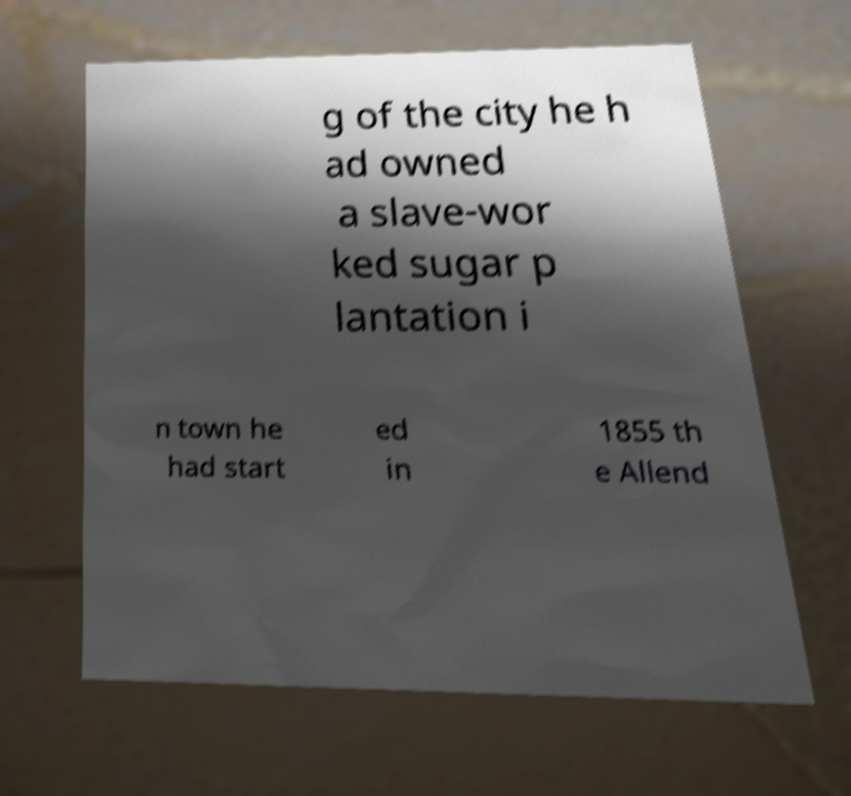Could you assist in decoding the text presented in this image and type it out clearly? g of the city he h ad owned a slave-wor ked sugar p lantation i n town he had start ed in 1855 th e Allend 